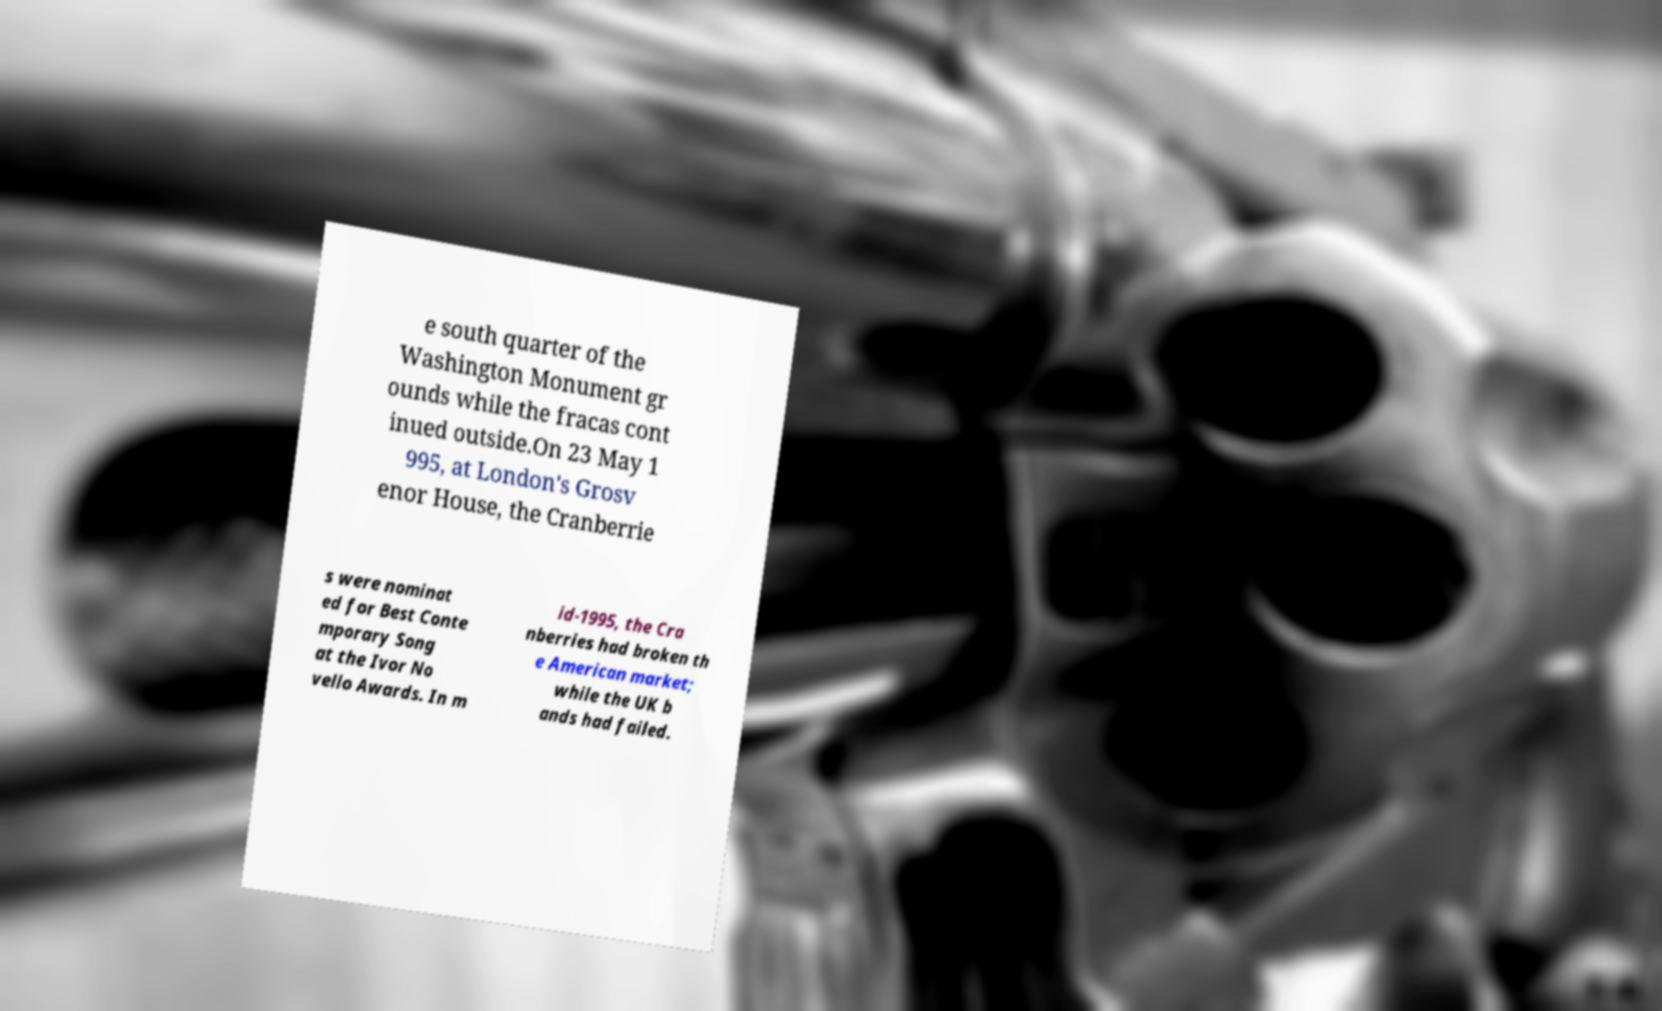There's text embedded in this image that I need extracted. Can you transcribe it verbatim? e south quarter of the Washington Monument gr ounds while the fracas cont inued outside.On 23 May 1 995, at London's Grosv enor House, the Cranberrie s were nominat ed for Best Conte mporary Song at the Ivor No vello Awards. In m id-1995, the Cra nberries had broken th e American market; while the UK b ands had failed. 